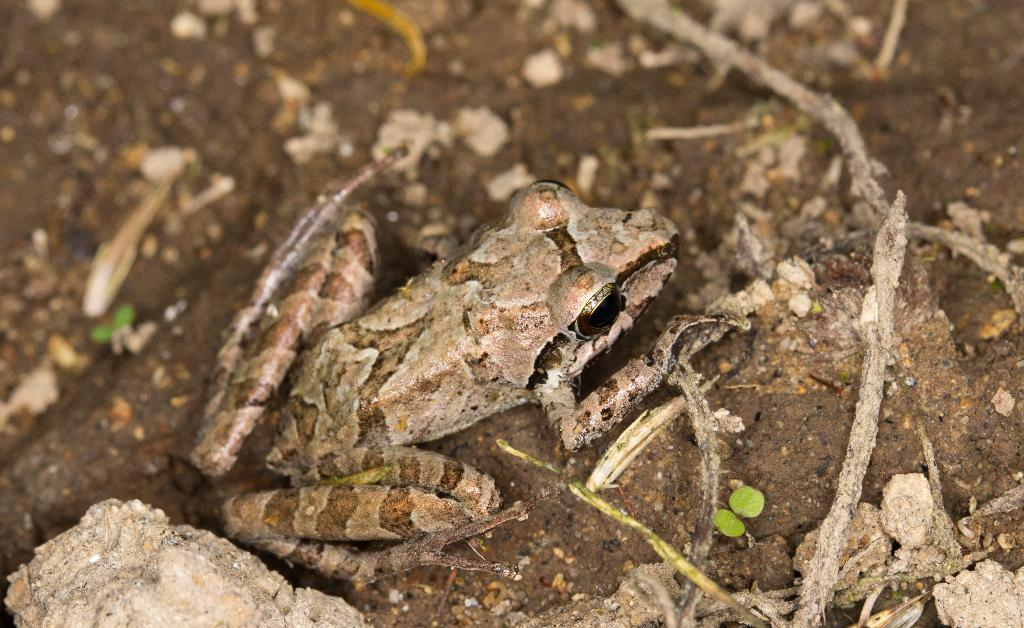What type of animal is in the image? There is a frog in the image. Where is the frog located in the image? The frog is on the ground. What type of secretary can be seen working in the image? There is no secretary present in the image; it features a frog on the ground. Can you tell me how many oceans are visible in the image? There are no oceans visible in the image; it features a frog on the ground. 